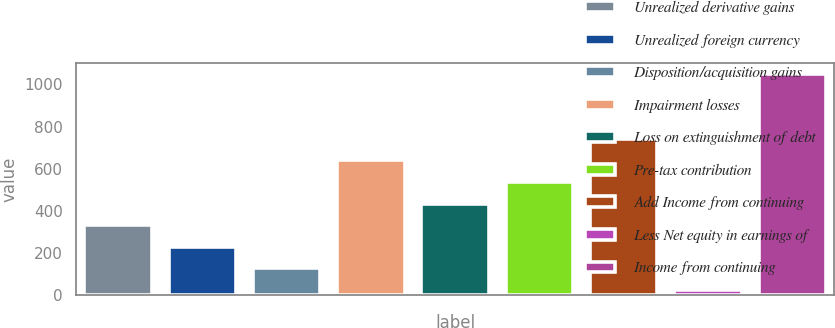Convert chart to OTSL. <chart><loc_0><loc_0><loc_500><loc_500><bar_chart><fcel>Unrealized derivative gains<fcel>Unrealized foreign currency<fcel>Disposition/acquisition gains<fcel>Impairment losses<fcel>Loss on extinguishment of debt<fcel>Pre-tax contribution<fcel>Add Income from continuing<fcel>Less Net equity in earnings of<fcel>Income from continuing<nl><fcel>331.9<fcel>229.6<fcel>127.3<fcel>638.8<fcel>434.2<fcel>536.5<fcel>741.1<fcel>25<fcel>1048<nl></chart> 